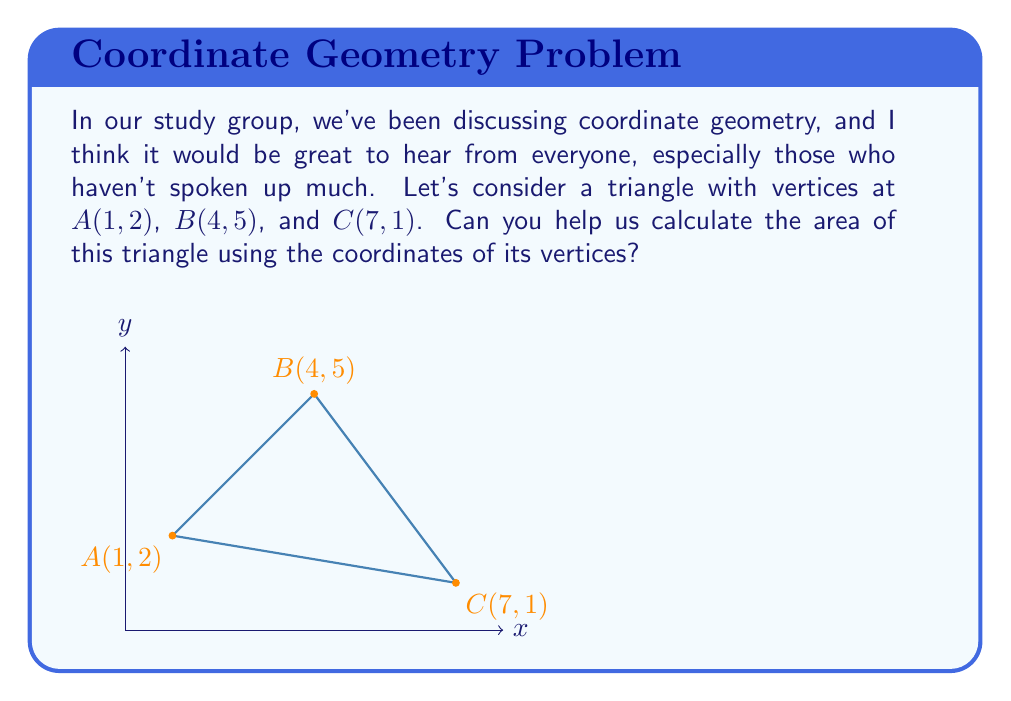Help me with this question. To calculate the area of a triangle using the coordinates of its vertices, we can use the formula:

$$\text{Area} = \frac{1}{2}|x_1(y_2 - y_3) + x_2(y_3 - y_1) + x_3(y_1 - y_2)|$$

Where $(x_1, y_1)$, $(x_2, y_2)$, and $(x_3, y_3)$ are the coordinates of the three vertices.

Let's substitute our coordinates:
$A(1, 2)$, so $x_1 = 1$, $y_1 = 2$
$B(4, 5)$, so $x_2 = 4$, $y_2 = 5$
$C(7, 1)$, so $x_3 = 7$, $y_3 = 1$

Now, let's plug these into our formula:

$$\begin{align*}
\text{Area} &= \frac{1}{2}|1(5 - 1) + 4(1 - 2) + 7(2 - 5)| \\
&= \frac{1}{2}|1(4) + 4(-1) + 7(-3)| \\
&= \frac{1}{2}|4 - 4 - 21| \\
&= \frac{1}{2}|-21| \\
&= \frac{1}{2}(21) \\
&= 10.5
\end{align*}$$

Therefore, the area of the triangle is 10.5 square units.
Answer: 10.5 square units 